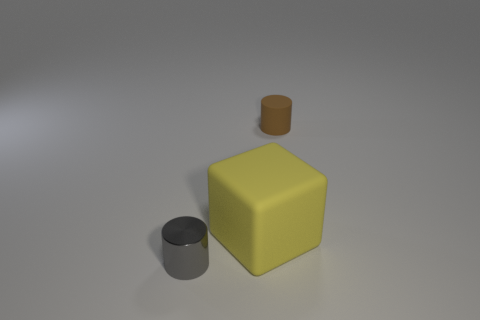Is there anything else that has the same shape as the yellow rubber object?
Offer a very short reply. No. There is a gray cylinder; how many brown cylinders are behind it?
Your answer should be compact. 1. Are there any other things that have the same size as the yellow matte cube?
Your response must be concise. No. The cylinder that is the same material as the cube is what color?
Provide a short and direct response. Brown. Is the shape of the tiny gray metal thing the same as the tiny brown object?
Provide a succinct answer. Yes. What number of small objects are both to the left of the yellow matte thing and to the right of the small metallic cylinder?
Ensure brevity in your answer.  0. What number of matte things are cylinders or blocks?
Your answer should be compact. 2. What size is the cylinder behind the shiny cylinder that is in front of the small rubber cylinder?
Ensure brevity in your answer.  Small. There is a yellow rubber thing that is on the left side of the tiny cylinder behind the gray cylinder; is there a metallic thing in front of it?
Give a very brief answer. Yes. Do the cylinder that is behind the large rubber object and the big yellow thing to the right of the small gray object have the same material?
Make the answer very short. Yes. 